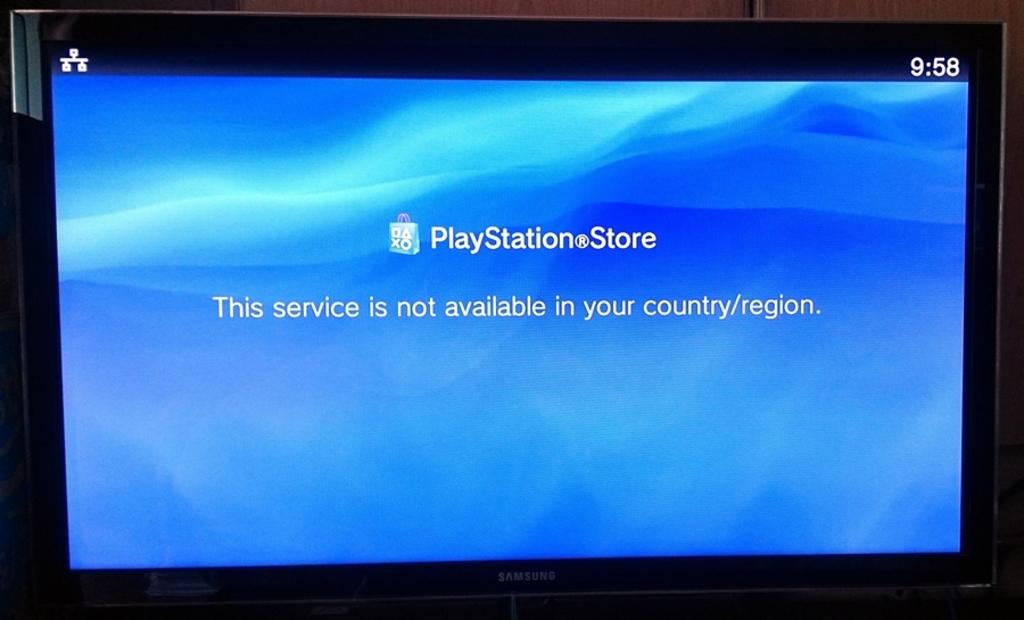What is the error?
Your answer should be compact. The service is not available in your country/region. This playstore available in the laptop?
Your response must be concise. No. 